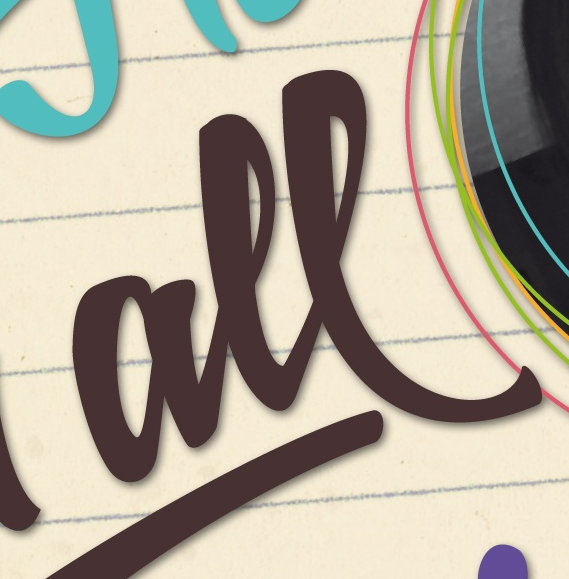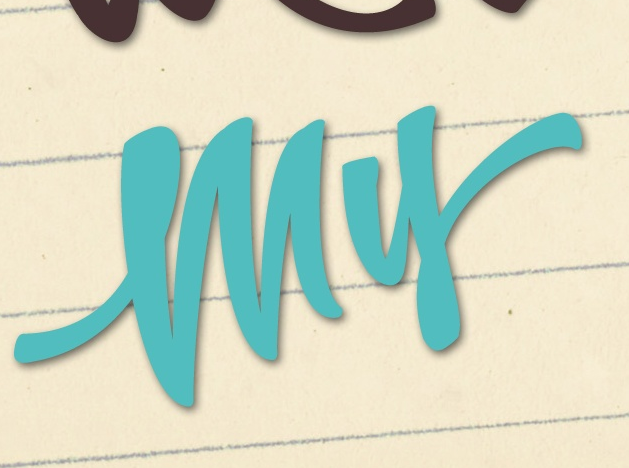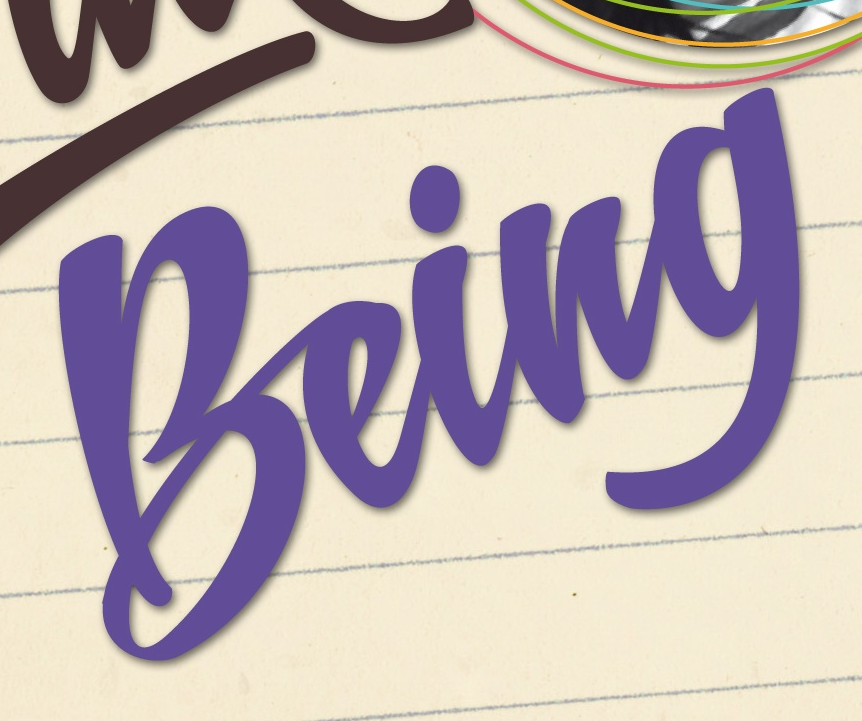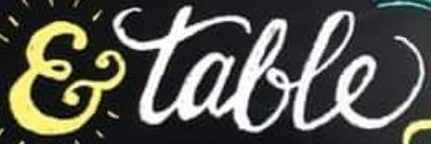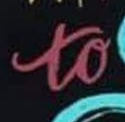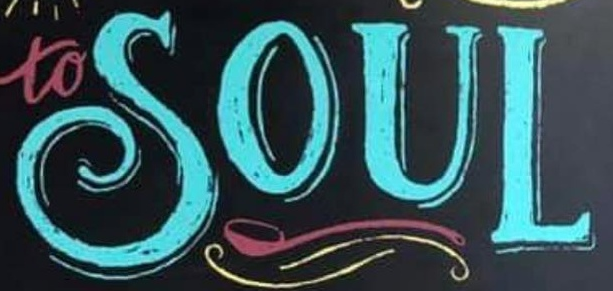What words can you see in these images in sequence, separated by a semicolon? all; my; being; &talle; to; SOUL 